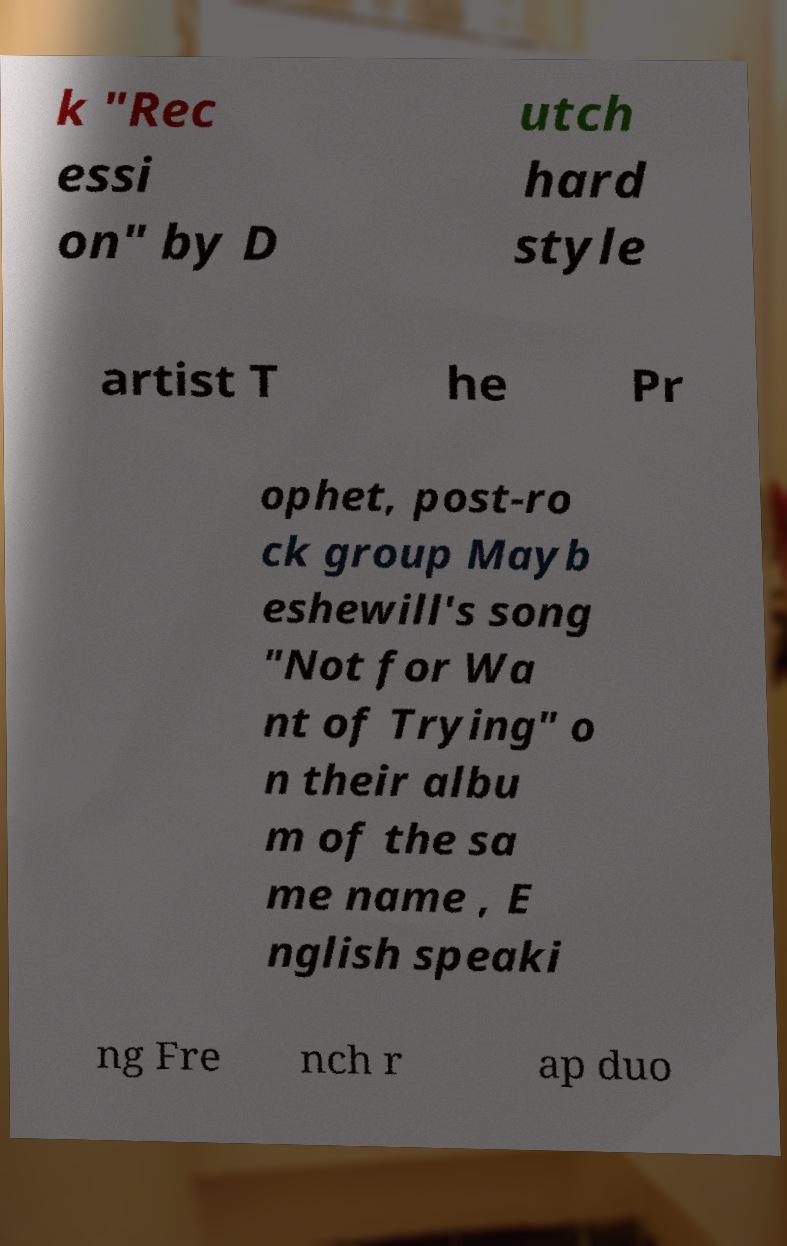Can you accurately transcribe the text from the provided image for me? k "Rec essi on" by D utch hard style artist T he Pr ophet, post-ro ck group Mayb eshewill's song "Not for Wa nt of Trying" o n their albu m of the sa me name , E nglish speaki ng Fre nch r ap duo 